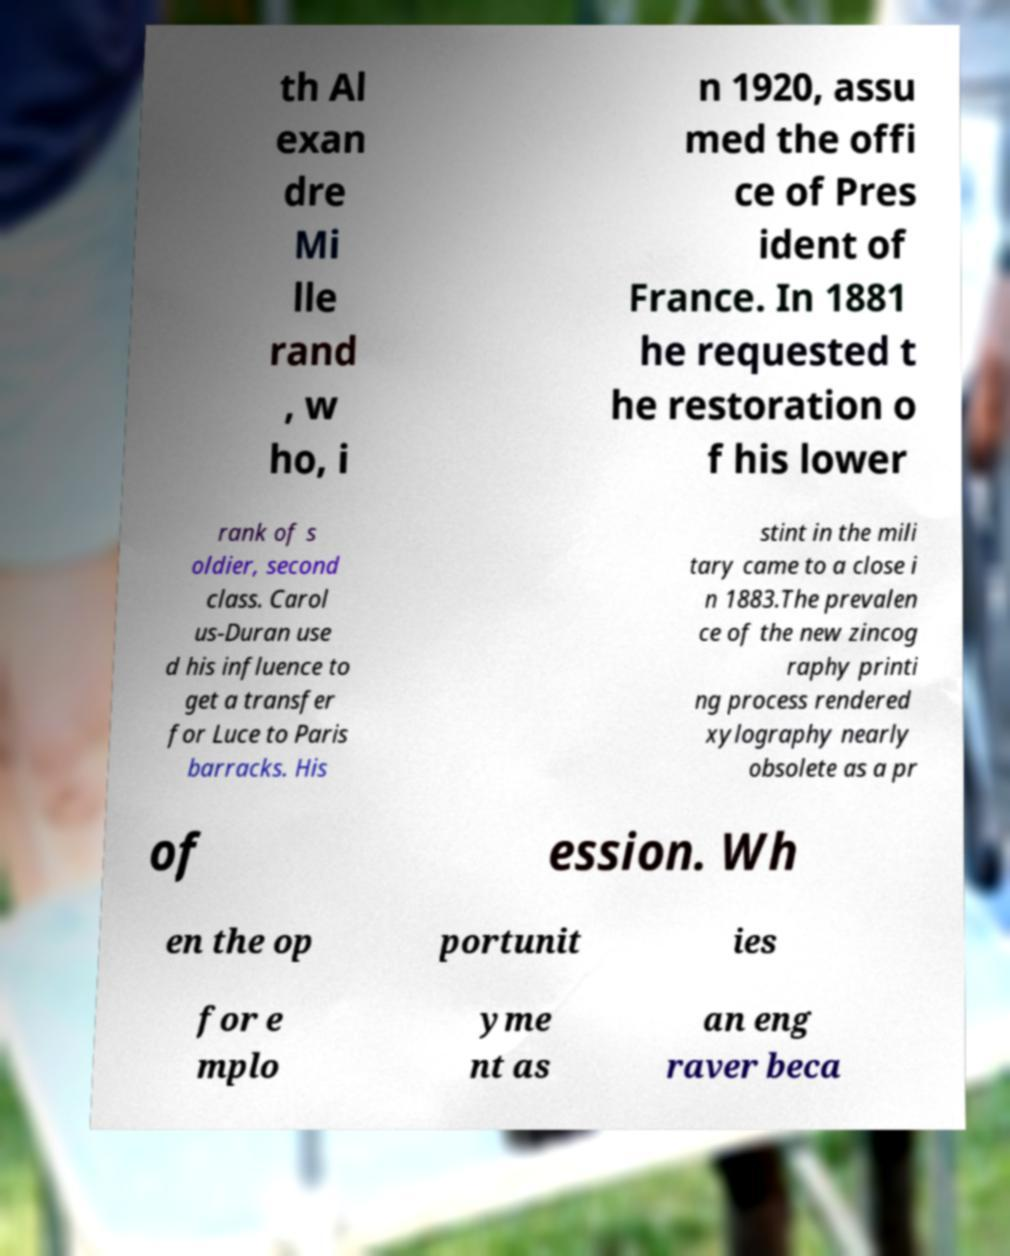Could you assist in decoding the text presented in this image and type it out clearly? th Al exan dre Mi lle rand , w ho, i n 1920, assu med the offi ce of Pres ident of France. In 1881 he requested t he restoration o f his lower rank of s oldier, second class. Carol us-Duran use d his influence to get a transfer for Luce to Paris barracks. His stint in the mili tary came to a close i n 1883.The prevalen ce of the new zincog raphy printi ng process rendered xylography nearly obsolete as a pr of ession. Wh en the op portunit ies for e mplo yme nt as an eng raver beca 